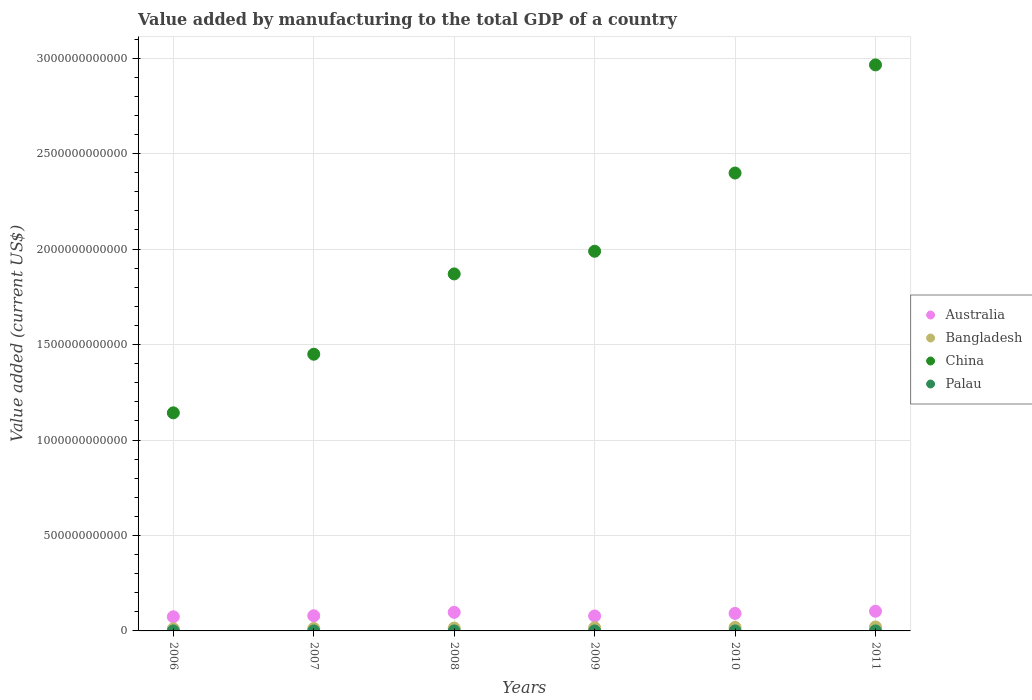What is the value added by manufacturing to the total GDP in Australia in 2008?
Keep it short and to the point. 9.74e+1. Across all years, what is the maximum value added by manufacturing to the total GDP in Palau?
Your response must be concise. 1.89e+06. Across all years, what is the minimum value added by manufacturing to the total GDP in China?
Your answer should be very brief. 1.14e+12. In which year was the value added by manufacturing to the total GDP in Bangladesh minimum?
Keep it short and to the point. 2006. What is the total value added by manufacturing to the total GDP in China in the graph?
Your response must be concise. 1.18e+13. What is the difference between the value added by manufacturing to the total GDP in China in 2007 and that in 2010?
Your answer should be compact. -9.49e+11. What is the difference between the value added by manufacturing to the total GDP in Australia in 2011 and the value added by manufacturing to the total GDP in China in 2009?
Ensure brevity in your answer.  -1.89e+12. What is the average value added by manufacturing to the total GDP in Bangladesh per year?
Keep it short and to the point. 1.58e+1. In the year 2007, what is the difference between the value added by manufacturing to the total GDP in China and value added by manufacturing to the total GDP in Australia?
Provide a short and direct response. 1.37e+12. What is the ratio of the value added by manufacturing to the total GDP in Palau in 2006 to that in 2011?
Give a very brief answer. 0.85. Is the value added by manufacturing to the total GDP in Palau in 2006 less than that in 2011?
Offer a terse response. Yes. Is the difference between the value added by manufacturing to the total GDP in China in 2009 and 2010 greater than the difference between the value added by manufacturing to the total GDP in Australia in 2009 and 2010?
Give a very brief answer. No. What is the difference between the highest and the second highest value added by manufacturing to the total GDP in Bangladesh?
Your answer should be compact. 1.99e+09. What is the difference between the highest and the lowest value added by manufacturing to the total GDP in China?
Your answer should be compact. 1.82e+12. Is the sum of the value added by manufacturing to the total GDP in Palau in 2009 and 2011 greater than the maximum value added by manufacturing to the total GDP in Australia across all years?
Make the answer very short. No. Is the value added by manufacturing to the total GDP in Palau strictly greater than the value added by manufacturing to the total GDP in China over the years?
Keep it short and to the point. No. How many years are there in the graph?
Keep it short and to the point. 6. What is the difference between two consecutive major ticks on the Y-axis?
Keep it short and to the point. 5.00e+11. Are the values on the major ticks of Y-axis written in scientific E-notation?
Give a very brief answer. No. Does the graph contain grids?
Your response must be concise. Yes. Where does the legend appear in the graph?
Ensure brevity in your answer.  Center right. How many legend labels are there?
Your answer should be compact. 4. How are the legend labels stacked?
Your answer should be very brief. Vertical. What is the title of the graph?
Offer a terse response. Value added by manufacturing to the total GDP of a country. Does "Seychelles" appear as one of the legend labels in the graph?
Provide a succinct answer. No. What is the label or title of the X-axis?
Keep it short and to the point. Years. What is the label or title of the Y-axis?
Offer a terse response. Value added (current US$). What is the Value added (current US$) in Australia in 2006?
Keep it short and to the point. 7.41e+1. What is the Value added (current US$) of Bangladesh in 2006?
Your answer should be very brief. 1.10e+1. What is the Value added (current US$) in China in 2006?
Keep it short and to the point. 1.14e+12. What is the Value added (current US$) in Palau in 2006?
Give a very brief answer. 1.52e+06. What is the Value added (current US$) of Australia in 2007?
Offer a very short reply. 7.95e+1. What is the Value added (current US$) in Bangladesh in 2007?
Offer a very short reply. 1.27e+1. What is the Value added (current US$) of China in 2007?
Keep it short and to the point. 1.45e+12. What is the Value added (current US$) in Palau in 2007?
Provide a succinct answer. 1.51e+06. What is the Value added (current US$) of Australia in 2008?
Make the answer very short. 9.74e+1. What is the Value added (current US$) in Bangladesh in 2008?
Offer a very short reply. 1.48e+1. What is the Value added (current US$) in China in 2008?
Your response must be concise. 1.87e+12. What is the Value added (current US$) of Palau in 2008?
Provide a short and direct response. 1.89e+06. What is the Value added (current US$) of Australia in 2009?
Offer a very short reply. 7.85e+1. What is the Value added (current US$) in Bangladesh in 2009?
Keep it short and to the point. 1.69e+1. What is the Value added (current US$) in China in 2009?
Ensure brevity in your answer.  1.99e+12. What is the Value added (current US$) in Palau in 2009?
Provide a succinct answer. 1.67e+06. What is the Value added (current US$) in Australia in 2010?
Your response must be concise. 9.17e+1. What is the Value added (current US$) of Bangladesh in 2010?
Give a very brief answer. 1.86e+1. What is the Value added (current US$) in China in 2010?
Your answer should be very brief. 2.40e+12. What is the Value added (current US$) in Palau in 2010?
Your response must be concise. 1.57e+06. What is the Value added (current US$) in Australia in 2011?
Provide a succinct answer. 1.03e+11. What is the Value added (current US$) in Bangladesh in 2011?
Make the answer very short. 2.06e+1. What is the Value added (current US$) of China in 2011?
Provide a short and direct response. 2.96e+12. What is the Value added (current US$) in Palau in 2011?
Your response must be concise. 1.79e+06. Across all years, what is the maximum Value added (current US$) in Australia?
Keep it short and to the point. 1.03e+11. Across all years, what is the maximum Value added (current US$) in Bangladesh?
Offer a very short reply. 2.06e+1. Across all years, what is the maximum Value added (current US$) in China?
Ensure brevity in your answer.  2.96e+12. Across all years, what is the maximum Value added (current US$) of Palau?
Your answer should be very brief. 1.89e+06. Across all years, what is the minimum Value added (current US$) of Australia?
Ensure brevity in your answer.  7.41e+1. Across all years, what is the minimum Value added (current US$) of Bangladesh?
Give a very brief answer. 1.10e+1. Across all years, what is the minimum Value added (current US$) in China?
Ensure brevity in your answer.  1.14e+12. Across all years, what is the minimum Value added (current US$) of Palau?
Your response must be concise. 1.51e+06. What is the total Value added (current US$) in Australia in the graph?
Keep it short and to the point. 5.24e+11. What is the total Value added (current US$) of Bangladesh in the graph?
Your response must be concise. 9.45e+1. What is the total Value added (current US$) of China in the graph?
Your answer should be compact. 1.18e+13. What is the total Value added (current US$) of Palau in the graph?
Your response must be concise. 9.95e+06. What is the difference between the Value added (current US$) of Australia in 2006 and that in 2007?
Keep it short and to the point. -5.44e+09. What is the difference between the Value added (current US$) of Bangladesh in 2006 and that in 2007?
Give a very brief answer. -1.69e+09. What is the difference between the Value added (current US$) of China in 2006 and that in 2007?
Your response must be concise. -3.07e+11. What is the difference between the Value added (current US$) in Palau in 2006 and that in 2007?
Your response must be concise. 8954.61. What is the difference between the Value added (current US$) in Australia in 2006 and that in 2008?
Offer a very short reply. -2.33e+1. What is the difference between the Value added (current US$) of Bangladesh in 2006 and that in 2008?
Your answer should be compact. -3.78e+09. What is the difference between the Value added (current US$) of China in 2006 and that in 2008?
Ensure brevity in your answer.  -7.28e+11. What is the difference between the Value added (current US$) in Palau in 2006 and that in 2008?
Your answer should be compact. -3.77e+05. What is the difference between the Value added (current US$) of Australia in 2006 and that in 2009?
Provide a short and direct response. -4.42e+09. What is the difference between the Value added (current US$) of Bangladesh in 2006 and that in 2009?
Give a very brief answer. -5.89e+09. What is the difference between the Value added (current US$) of China in 2006 and that in 2009?
Your answer should be very brief. -8.46e+11. What is the difference between the Value added (current US$) in Palau in 2006 and that in 2009?
Your answer should be very brief. -1.59e+05. What is the difference between the Value added (current US$) of Australia in 2006 and that in 2010?
Provide a succinct answer. -1.77e+1. What is the difference between the Value added (current US$) of Bangladesh in 2006 and that in 2010?
Keep it short and to the point. -7.59e+09. What is the difference between the Value added (current US$) of China in 2006 and that in 2010?
Make the answer very short. -1.26e+12. What is the difference between the Value added (current US$) in Palau in 2006 and that in 2010?
Give a very brief answer. -5.37e+04. What is the difference between the Value added (current US$) in Australia in 2006 and that in 2011?
Offer a very short reply. -2.90e+1. What is the difference between the Value added (current US$) of Bangladesh in 2006 and that in 2011?
Make the answer very short. -9.58e+09. What is the difference between the Value added (current US$) of China in 2006 and that in 2011?
Offer a terse response. -1.82e+12. What is the difference between the Value added (current US$) in Palau in 2006 and that in 2011?
Ensure brevity in your answer.  -2.74e+05. What is the difference between the Value added (current US$) in Australia in 2007 and that in 2008?
Offer a very short reply. -1.79e+1. What is the difference between the Value added (current US$) of Bangladesh in 2007 and that in 2008?
Your answer should be very brief. -2.09e+09. What is the difference between the Value added (current US$) in China in 2007 and that in 2008?
Ensure brevity in your answer.  -4.21e+11. What is the difference between the Value added (current US$) in Palau in 2007 and that in 2008?
Your answer should be compact. -3.86e+05. What is the difference between the Value added (current US$) of Australia in 2007 and that in 2009?
Your response must be concise. 1.02e+09. What is the difference between the Value added (current US$) in Bangladesh in 2007 and that in 2009?
Offer a very short reply. -4.20e+09. What is the difference between the Value added (current US$) in China in 2007 and that in 2009?
Provide a succinct answer. -5.39e+11. What is the difference between the Value added (current US$) in Palau in 2007 and that in 2009?
Your response must be concise. -1.68e+05. What is the difference between the Value added (current US$) in Australia in 2007 and that in 2010?
Ensure brevity in your answer.  -1.22e+1. What is the difference between the Value added (current US$) of Bangladesh in 2007 and that in 2010?
Provide a succinct answer. -5.90e+09. What is the difference between the Value added (current US$) in China in 2007 and that in 2010?
Your answer should be very brief. -9.49e+11. What is the difference between the Value added (current US$) of Palau in 2007 and that in 2010?
Your response must be concise. -6.27e+04. What is the difference between the Value added (current US$) in Australia in 2007 and that in 2011?
Ensure brevity in your answer.  -2.36e+1. What is the difference between the Value added (current US$) in Bangladesh in 2007 and that in 2011?
Keep it short and to the point. -7.89e+09. What is the difference between the Value added (current US$) in China in 2007 and that in 2011?
Offer a terse response. -1.52e+12. What is the difference between the Value added (current US$) of Palau in 2007 and that in 2011?
Your response must be concise. -2.83e+05. What is the difference between the Value added (current US$) of Australia in 2008 and that in 2009?
Your response must be concise. 1.89e+1. What is the difference between the Value added (current US$) in Bangladesh in 2008 and that in 2009?
Offer a very short reply. -2.11e+09. What is the difference between the Value added (current US$) of China in 2008 and that in 2009?
Provide a succinct answer. -1.19e+11. What is the difference between the Value added (current US$) in Palau in 2008 and that in 2009?
Give a very brief answer. 2.19e+05. What is the difference between the Value added (current US$) of Australia in 2008 and that in 2010?
Provide a succinct answer. 5.64e+09. What is the difference between the Value added (current US$) of Bangladesh in 2008 and that in 2010?
Provide a short and direct response. -3.81e+09. What is the difference between the Value added (current US$) of China in 2008 and that in 2010?
Provide a short and direct response. -5.29e+11. What is the difference between the Value added (current US$) in Palau in 2008 and that in 2010?
Your answer should be very brief. 3.24e+05. What is the difference between the Value added (current US$) of Australia in 2008 and that in 2011?
Offer a terse response. -5.73e+09. What is the difference between the Value added (current US$) of Bangladesh in 2008 and that in 2011?
Provide a short and direct response. -5.80e+09. What is the difference between the Value added (current US$) of China in 2008 and that in 2011?
Your answer should be compact. -1.09e+12. What is the difference between the Value added (current US$) in Palau in 2008 and that in 2011?
Ensure brevity in your answer.  1.03e+05. What is the difference between the Value added (current US$) in Australia in 2009 and that in 2010?
Your answer should be compact. -1.32e+1. What is the difference between the Value added (current US$) of Bangladesh in 2009 and that in 2010?
Your response must be concise. -1.70e+09. What is the difference between the Value added (current US$) of China in 2009 and that in 2010?
Offer a very short reply. -4.10e+11. What is the difference between the Value added (current US$) of Palau in 2009 and that in 2010?
Your answer should be compact. 1.05e+05. What is the difference between the Value added (current US$) of Australia in 2009 and that in 2011?
Your answer should be compact. -2.46e+1. What is the difference between the Value added (current US$) of Bangladesh in 2009 and that in 2011?
Make the answer very short. -3.69e+09. What is the difference between the Value added (current US$) of China in 2009 and that in 2011?
Give a very brief answer. -9.76e+11. What is the difference between the Value added (current US$) of Palau in 2009 and that in 2011?
Ensure brevity in your answer.  -1.16e+05. What is the difference between the Value added (current US$) in Australia in 2010 and that in 2011?
Your response must be concise. -1.14e+1. What is the difference between the Value added (current US$) in Bangladesh in 2010 and that in 2011?
Your answer should be compact. -1.99e+09. What is the difference between the Value added (current US$) of China in 2010 and that in 2011?
Your answer should be very brief. -5.66e+11. What is the difference between the Value added (current US$) of Palau in 2010 and that in 2011?
Your answer should be very brief. -2.21e+05. What is the difference between the Value added (current US$) in Australia in 2006 and the Value added (current US$) in Bangladesh in 2007?
Offer a terse response. 6.14e+1. What is the difference between the Value added (current US$) in Australia in 2006 and the Value added (current US$) in China in 2007?
Give a very brief answer. -1.38e+12. What is the difference between the Value added (current US$) in Australia in 2006 and the Value added (current US$) in Palau in 2007?
Provide a succinct answer. 7.41e+1. What is the difference between the Value added (current US$) of Bangladesh in 2006 and the Value added (current US$) of China in 2007?
Give a very brief answer. -1.44e+12. What is the difference between the Value added (current US$) of Bangladesh in 2006 and the Value added (current US$) of Palau in 2007?
Make the answer very short. 1.10e+1. What is the difference between the Value added (current US$) in China in 2006 and the Value added (current US$) in Palau in 2007?
Your answer should be very brief. 1.14e+12. What is the difference between the Value added (current US$) of Australia in 2006 and the Value added (current US$) of Bangladesh in 2008?
Keep it short and to the point. 5.93e+1. What is the difference between the Value added (current US$) of Australia in 2006 and the Value added (current US$) of China in 2008?
Give a very brief answer. -1.80e+12. What is the difference between the Value added (current US$) in Australia in 2006 and the Value added (current US$) in Palau in 2008?
Give a very brief answer. 7.41e+1. What is the difference between the Value added (current US$) of Bangladesh in 2006 and the Value added (current US$) of China in 2008?
Keep it short and to the point. -1.86e+12. What is the difference between the Value added (current US$) of Bangladesh in 2006 and the Value added (current US$) of Palau in 2008?
Ensure brevity in your answer.  1.10e+1. What is the difference between the Value added (current US$) in China in 2006 and the Value added (current US$) in Palau in 2008?
Offer a very short reply. 1.14e+12. What is the difference between the Value added (current US$) in Australia in 2006 and the Value added (current US$) in Bangladesh in 2009?
Make the answer very short. 5.72e+1. What is the difference between the Value added (current US$) of Australia in 2006 and the Value added (current US$) of China in 2009?
Make the answer very short. -1.91e+12. What is the difference between the Value added (current US$) in Australia in 2006 and the Value added (current US$) in Palau in 2009?
Your answer should be compact. 7.41e+1. What is the difference between the Value added (current US$) of Bangladesh in 2006 and the Value added (current US$) of China in 2009?
Offer a very short reply. -1.98e+12. What is the difference between the Value added (current US$) in Bangladesh in 2006 and the Value added (current US$) in Palau in 2009?
Keep it short and to the point. 1.10e+1. What is the difference between the Value added (current US$) of China in 2006 and the Value added (current US$) of Palau in 2009?
Give a very brief answer. 1.14e+12. What is the difference between the Value added (current US$) in Australia in 2006 and the Value added (current US$) in Bangladesh in 2010?
Your answer should be very brief. 5.55e+1. What is the difference between the Value added (current US$) of Australia in 2006 and the Value added (current US$) of China in 2010?
Your answer should be very brief. -2.32e+12. What is the difference between the Value added (current US$) of Australia in 2006 and the Value added (current US$) of Palau in 2010?
Provide a short and direct response. 7.41e+1. What is the difference between the Value added (current US$) of Bangladesh in 2006 and the Value added (current US$) of China in 2010?
Make the answer very short. -2.39e+12. What is the difference between the Value added (current US$) of Bangladesh in 2006 and the Value added (current US$) of Palau in 2010?
Your answer should be compact. 1.10e+1. What is the difference between the Value added (current US$) in China in 2006 and the Value added (current US$) in Palau in 2010?
Your answer should be compact. 1.14e+12. What is the difference between the Value added (current US$) in Australia in 2006 and the Value added (current US$) in Bangladesh in 2011?
Provide a short and direct response. 5.35e+1. What is the difference between the Value added (current US$) in Australia in 2006 and the Value added (current US$) in China in 2011?
Ensure brevity in your answer.  -2.89e+12. What is the difference between the Value added (current US$) of Australia in 2006 and the Value added (current US$) of Palau in 2011?
Provide a succinct answer. 7.41e+1. What is the difference between the Value added (current US$) of Bangladesh in 2006 and the Value added (current US$) of China in 2011?
Your response must be concise. -2.95e+12. What is the difference between the Value added (current US$) of Bangladesh in 2006 and the Value added (current US$) of Palau in 2011?
Make the answer very short. 1.10e+1. What is the difference between the Value added (current US$) in China in 2006 and the Value added (current US$) in Palau in 2011?
Make the answer very short. 1.14e+12. What is the difference between the Value added (current US$) of Australia in 2007 and the Value added (current US$) of Bangladesh in 2008?
Keep it short and to the point. 6.47e+1. What is the difference between the Value added (current US$) in Australia in 2007 and the Value added (current US$) in China in 2008?
Give a very brief answer. -1.79e+12. What is the difference between the Value added (current US$) of Australia in 2007 and the Value added (current US$) of Palau in 2008?
Give a very brief answer. 7.95e+1. What is the difference between the Value added (current US$) in Bangladesh in 2007 and the Value added (current US$) in China in 2008?
Provide a succinct answer. -1.86e+12. What is the difference between the Value added (current US$) in Bangladesh in 2007 and the Value added (current US$) in Palau in 2008?
Your answer should be compact. 1.27e+1. What is the difference between the Value added (current US$) in China in 2007 and the Value added (current US$) in Palau in 2008?
Offer a very short reply. 1.45e+12. What is the difference between the Value added (current US$) of Australia in 2007 and the Value added (current US$) of Bangladesh in 2009?
Provide a succinct answer. 6.26e+1. What is the difference between the Value added (current US$) of Australia in 2007 and the Value added (current US$) of China in 2009?
Your response must be concise. -1.91e+12. What is the difference between the Value added (current US$) in Australia in 2007 and the Value added (current US$) in Palau in 2009?
Keep it short and to the point. 7.95e+1. What is the difference between the Value added (current US$) of Bangladesh in 2007 and the Value added (current US$) of China in 2009?
Give a very brief answer. -1.98e+12. What is the difference between the Value added (current US$) in Bangladesh in 2007 and the Value added (current US$) in Palau in 2009?
Your answer should be very brief. 1.27e+1. What is the difference between the Value added (current US$) of China in 2007 and the Value added (current US$) of Palau in 2009?
Offer a terse response. 1.45e+12. What is the difference between the Value added (current US$) in Australia in 2007 and the Value added (current US$) in Bangladesh in 2010?
Provide a short and direct response. 6.09e+1. What is the difference between the Value added (current US$) of Australia in 2007 and the Value added (current US$) of China in 2010?
Provide a succinct answer. -2.32e+12. What is the difference between the Value added (current US$) in Australia in 2007 and the Value added (current US$) in Palau in 2010?
Provide a succinct answer. 7.95e+1. What is the difference between the Value added (current US$) of Bangladesh in 2007 and the Value added (current US$) of China in 2010?
Provide a succinct answer. -2.39e+12. What is the difference between the Value added (current US$) in Bangladesh in 2007 and the Value added (current US$) in Palau in 2010?
Keep it short and to the point. 1.27e+1. What is the difference between the Value added (current US$) in China in 2007 and the Value added (current US$) in Palau in 2010?
Your answer should be compact. 1.45e+12. What is the difference between the Value added (current US$) in Australia in 2007 and the Value added (current US$) in Bangladesh in 2011?
Keep it short and to the point. 5.89e+1. What is the difference between the Value added (current US$) in Australia in 2007 and the Value added (current US$) in China in 2011?
Offer a very short reply. -2.89e+12. What is the difference between the Value added (current US$) in Australia in 2007 and the Value added (current US$) in Palau in 2011?
Ensure brevity in your answer.  7.95e+1. What is the difference between the Value added (current US$) in Bangladesh in 2007 and the Value added (current US$) in China in 2011?
Your response must be concise. -2.95e+12. What is the difference between the Value added (current US$) in Bangladesh in 2007 and the Value added (current US$) in Palau in 2011?
Your answer should be compact. 1.27e+1. What is the difference between the Value added (current US$) in China in 2007 and the Value added (current US$) in Palau in 2011?
Offer a terse response. 1.45e+12. What is the difference between the Value added (current US$) of Australia in 2008 and the Value added (current US$) of Bangladesh in 2009?
Make the answer very short. 8.05e+1. What is the difference between the Value added (current US$) of Australia in 2008 and the Value added (current US$) of China in 2009?
Provide a succinct answer. -1.89e+12. What is the difference between the Value added (current US$) in Australia in 2008 and the Value added (current US$) in Palau in 2009?
Your answer should be very brief. 9.74e+1. What is the difference between the Value added (current US$) in Bangladesh in 2008 and the Value added (current US$) in China in 2009?
Your answer should be very brief. -1.97e+12. What is the difference between the Value added (current US$) in Bangladesh in 2008 and the Value added (current US$) in Palau in 2009?
Ensure brevity in your answer.  1.48e+1. What is the difference between the Value added (current US$) of China in 2008 and the Value added (current US$) of Palau in 2009?
Ensure brevity in your answer.  1.87e+12. What is the difference between the Value added (current US$) of Australia in 2008 and the Value added (current US$) of Bangladesh in 2010?
Provide a short and direct response. 7.88e+1. What is the difference between the Value added (current US$) of Australia in 2008 and the Value added (current US$) of China in 2010?
Give a very brief answer. -2.30e+12. What is the difference between the Value added (current US$) in Australia in 2008 and the Value added (current US$) in Palau in 2010?
Your answer should be very brief. 9.74e+1. What is the difference between the Value added (current US$) of Bangladesh in 2008 and the Value added (current US$) of China in 2010?
Ensure brevity in your answer.  -2.38e+12. What is the difference between the Value added (current US$) in Bangladesh in 2008 and the Value added (current US$) in Palau in 2010?
Your answer should be very brief. 1.48e+1. What is the difference between the Value added (current US$) of China in 2008 and the Value added (current US$) of Palau in 2010?
Provide a succinct answer. 1.87e+12. What is the difference between the Value added (current US$) in Australia in 2008 and the Value added (current US$) in Bangladesh in 2011?
Provide a succinct answer. 7.68e+1. What is the difference between the Value added (current US$) of Australia in 2008 and the Value added (current US$) of China in 2011?
Give a very brief answer. -2.87e+12. What is the difference between the Value added (current US$) of Australia in 2008 and the Value added (current US$) of Palau in 2011?
Provide a succinct answer. 9.74e+1. What is the difference between the Value added (current US$) of Bangladesh in 2008 and the Value added (current US$) of China in 2011?
Keep it short and to the point. -2.95e+12. What is the difference between the Value added (current US$) in Bangladesh in 2008 and the Value added (current US$) in Palau in 2011?
Offer a terse response. 1.48e+1. What is the difference between the Value added (current US$) in China in 2008 and the Value added (current US$) in Palau in 2011?
Make the answer very short. 1.87e+12. What is the difference between the Value added (current US$) in Australia in 2009 and the Value added (current US$) in Bangladesh in 2010?
Offer a very short reply. 5.99e+1. What is the difference between the Value added (current US$) of Australia in 2009 and the Value added (current US$) of China in 2010?
Make the answer very short. -2.32e+12. What is the difference between the Value added (current US$) in Australia in 2009 and the Value added (current US$) in Palau in 2010?
Offer a very short reply. 7.85e+1. What is the difference between the Value added (current US$) in Bangladesh in 2009 and the Value added (current US$) in China in 2010?
Give a very brief answer. -2.38e+12. What is the difference between the Value added (current US$) of Bangladesh in 2009 and the Value added (current US$) of Palau in 2010?
Ensure brevity in your answer.  1.69e+1. What is the difference between the Value added (current US$) of China in 2009 and the Value added (current US$) of Palau in 2010?
Your response must be concise. 1.99e+12. What is the difference between the Value added (current US$) of Australia in 2009 and the Value added (current US$) of Bangladesh in 2011?
Make the answer very short. 5.79e+1. What is the difference between the Value added (current US$) of Australia in 2009 and the Value added (current US$) of China in 2011?
Provide a short and direct response. -2.89e+12. What is the difference between the Value added (current US$) in Australia in 2009 and the Value added (current US$) in Palau in 2011?
Your answer should be very brief. 7.85e+1. What is the difference between the Value added (current US$) of Bangladesh in 2009 and the Value added (current US$) of China in 2011?
Provide a succinct answer. -2.95e+12. What is the difference between the Value added (current US$) in Bangladesh in 2009 and the Value added (current US$) in Palau in 2011?
Your answer should be very brief. 1.69e+1. What is the difference between the Value added (current US$) in China in 2009 and the Value added (current US$) in Palau in 2011?
Give a very brief answer. 1.99e+12. What is the difference between the Value added (current US$) in Australia in 2010 and the Value added (current US$) in Bangladesh in 2011?
Your response must be concise. 7.11e+1. What is the difference between the Value added (current US$) of Australia in 2010 and the Value added (current US$) of China in 2011?
Make the answer very short. -2.87e+12. What is the difference between the Value added (current US$) of Australia in 2010 and the Value added (current US$) of Palau in 2011?
Give a very brief answer. 9.17e+1. What is the difference between the Value added (current US$) in Bangladesh in 2010 and the Value added (current US$) in China in 2011?
Give a very brief answer. -2.95e+12. What is the difference between the Value added (current US$) of Bangladesh in 2010 and the Value added (current US$) of Palau in 2011?
Offer a very short reply. 1.86e+1. What is the difference between the Value added (current US$) of China in 2010 and the Value added (current US$) of Palau in 2011?
Keep it short and to the point. 2.40e+12. What is the average Value added (current US$) in Australia per year?
Your answer should be very brief. 8.74e+1. What is the average Value added (current US$) of Bangladesh per year?
Provide a short and direct response. 1.58e+1. What is the average Value added (current US$) of China per year?
Your answer should be compact. 1.97e+12. What is the average Value added (current US$) in Palau per year?
Your answer should be very brief. 1.66e+06. In the year 2006, what is the difference between the Value added (current US$) in Australia and Value added (current US$) in Bangladesh?
Your response must be concise. 6.31e+1. In the year 2006, what is the difference between the Value added (current US$) of Australia and Value added (current US$) of China?
Give a very brief answer. -1.07e+12. In the year 2006, what is the difference between the Value added (current US$) of Australia and Value added (current US$) of Palau?
Your response must be concise. 7.41e+1. In the year 2006, what is the difference between the Value added (current US$) of Bangladesh and Value added (current US$) of China?
Give a very brief answer. -1.13e+12. In the year 2006, what is the difference between the Value added (current US$) in Bangladesh and Value added (current US$) in Palau?
Offer a very short reply. 1.10e+1. In the year 2006, what is the difference between the Value added (current US$) of China and Value added (current US$) of Palau?
Offer a terse response. 1.14e+12. In the year 2007, what is the difference between the Value added (current US$) of Australia and Value added (current US$) of Bangladesh?
Ensure brevity in your answer.  6.68e+1. In the year 2007, what is the difference between the Value added (current US$) in Australia and Value added (current US$) in China?
Offer a very short reply. -1.37e+12. In the year 2007, what is the difference between the Value added (current US$) of Australia and Value added (current US$) of Palau?
Your response must be concise. 7.95e+1. In the year 2007, what is the difference between the Value added (current US$) in Bangladesh and Value added (current US$) in China?
Offer a terse response. -1.44e+12. In the year 2007, what is the difference between the Value added (current US$) in Bangladesh and Value added (current US$) in Palau?
Your answer should be compact. 1.27e+1. In the year 2007, what is the difference between the Value added (current US$) of China and Value added (current US$) of Palau?
Keep it short and to the point. 1.45e+12. In the year 2008, what is the difference between the Value added (current US$) in Australia and Value added (current US$) in Bangladesh?
Your response must be concise. 8.26e+1. In the year 2008, what is the difference between the Value added (current US$) in Australia and Value added (current US$) in China?
Offer a terse response. -1.77e+12. In the year 2008, what is the difference between the Value added (current US$) in Australia and Value added (current US$) in Palau?
Ensure brevity in your answer.  9.74e+1. In the year 2008, what is the difference between the Value added (current US$) of Bangladesh and Value added (current US$) of China?
Keep it short and to the point. -1.86e+12. In the year 2008, what is the difference between the Value added (current US$) of Bangladesh and Value added (current US$) of Palau?
Provide a succinct answer. 1.48e+1. In the year 2008, what is the difference between the Value added (current US$) in China and Value added (current US$) in Palau?
Your answer should be compact. 1.87e+12. In the year 2009, what is the difference between the Value added (current US$) of Australia and Value added (current US$) of Bangladesh?
Keep it short and to the point. 6.16e+1. In the year 2009, what is the difference between the Value added (current US$) in Australia and Value added (current US$) in China?
Ensure brevity in your answer.  -1.91e+12. In the year 2009, what is the difference between the Value added (current US$) in Australia and Value added (current US$) in Palau?
Give a very brief answer. 7.85e+1. In the year 2009, what is the difference between the Value added (current US$) in Bangladesh and Value added (current US$) in China?
Give a very brief answer. -1.97e+12. In the year 2009, what is the difference between the Value added (current US$) in Bangladesh and Value added (current US$) in Palau?
Offer a terse response. 1.69e+1. In the year 2009, what is the difference between the Value added (current US$) of China and Value added (current US$) of Palau?
Give a very brief answer. 1.99e+12. In the year 2010, what is the difference between the Value added (current US$) in Australia and Value added (current US$) in Bangladesh?
Your answer should be very brief. 7.31e+1. In the year 2010, what is the difference between the Value added (current US$) in Australia and Value added (current US$) in China?
Your answer should be compact. -2.31e+12. In the year 2010, what is the difference between the Value added (current US$) in Australia and Value added (current US$) in Palau?
Offer a very short reply. 9.17e+1. In the year 2010, what is the difference between the Value added (current US$) in Bangladesh and Value added (current US$) in China?
Your answer should be very brief. -2.38e+12. In the year 2010, what is the difference between the Value added (current US$) in Bangladesh and Value added (current US$) in Palau?
Ensure brevity in your answer.  1.86e+1. In the year 2010, what is the difference between the Value added (current US$) in China and Value added (current US$) in Palau?
Keep it short and to the point. 2.40e+12. In the year 2011, what is the difference between the Value added (current US$) in Australia and Value added (current US$) in Bangladesh?
Make the answer very short. 8.25e+1. In the year 2011, what is the difference between the Value added (current US$) of Australia and Value added (current US$) of China?
Your answer should be compact. -2.86e+12. In the year 2011, what is the difference between the Value added (current US$) of Australia and Value added (current US$) of Palau?
Give a very brief answer. 1.03e+11. In the year 2011, what is the difference between the Value added (current US$) in Bangladesh and Value added (current US$) in China?
Keep it short and to the point. -2.94e+12. In the year 2011, what is the difference between the Value added (current US$) in Bangladesh and Value added (current US$) in Palau?
Keep it short and to the point. 2.06e+1. In the year 2011, what is the difference between the Value added (current US$) in China and Value added (current US$) in Palau?
Keep it short and to the point. 2.96e+12. What is the ratio of the Value added (current US$) in Australia in 2006 to that in 2007?
Offer a terse response. 0.93. What is the ratio of the Value added (current US$) of Bangladesh in 2006 to that in 2007?
Offer a terse response. 0.87. What is the ratio of the Value added (current US$) of China in 2006 to that in 2007?
Ensure brevity in your answer.  0.79. What is the ratio of the Value added (current US$) in Palau in 2006 to that in 2007?
Your answer should be compact. 1.01. What is the ratio of the Value added (current US$) in Australia in 2006 to that in 2008?
Give a very brief answer. 0.76. What is the ratio of the Value added (current US$) of Bangladesh in 2006 to that in 2008?
Provide a succinct answer. 0.74. What is the ratio of the Value added (current US$) of China in 2006 to that in 2008?
Provide a short and direct response. 0.61. What is the ratio of the Value added (current US$) of Palau in 2006 to that in 2008?
Make the answer very short. 0.8. What is the ratio of the Value added (current US$) of Australia in 2006 to that in 2009?
Keep it short and to the point. 0.94. What is the ratio of the Value added (current US$) in Bangladesh in 2006 to that in 2009?
Offer a terse response. 0.65. What is the ratio of the Value added (current US$) in China in 2006 to that in 2009?
Your response must be concise. 0.57. What is the ratio of the Value added (current US$) of Palau in 2006 to that in 2009?
Provide a succinct answer. 0.91. What is the ratio of the Value added (current US$) in Australia in 2006 to that in 2010?
Give a very brief answer. 0.81. What is the ratio of the Value added (current US$) of Bangladesh in 2006 to that in 2010?
Make the answer very short. 0.59. What is the ratio of the Value added (current US$) in China in 2006 to that in 2010?
Make the answer very short. 0.48. What is the ratio of the Value added (current US$) in Palau in 2006 to that in 2010?
Give a very brief answer. 0.97. What is the ratio of the Value added (current US$) in Australia in 2006 to that in 2011?
Your response must be concise. 0.72. What is the ratio of the Value added (current US$) in Bangladesh in 2006 to that in 2011?
Your answer should be compact. 0.53. What is the ratio of the Value added (current US$) in China in 2006 to that in 2011?
Offer a terse response. 0.39. What is the ratio of the Value added (current US$) in Palau in 2006 to that in 2011?
Your response must be concise. 0.85. What is the ratio of the Value added (current US$) of Australia in 2007 to that in 2008?
Ensure brevity in your answer.  0.82. What is the ratio of the Value added (current US$) in Bangladesh in 2007 to that in 2008?
Keep it short and to the point. 0.86. What is the ratio of the Value added (current US$) in China in 2007 to that in 2008?
Offer a very short reply. 0.78. What is the ratio of the Value added (current US$) in Palau in 2007 to that in 2008?
Offer a very short reply. 0.8. What is the ratio of the Value added (current US$) of Bangladesh in 2007 to that in 2009?
Provide a succinct answer. 0.75. What is the ratio of the Value added (current US$) in China in 2007 to that in 2009?
Offer a very short reply. 0.73. What is the ratio of the Value added (current US$) in Australia in 2007 to that in 2010?
Provide a short and direct response. 0.87. What is the ratio of the Value added (current US$) of Bangladesh in 2007 to that in 2010?
Provide a short and direct response. 0.68. What is the ratio of the Value added (current US$) in China in 2007 to that in 2010?
Keep it short and to the point. 0.6. What is the ratio of the Value added (current US$) in Palau in 2007 to that in 2010?
Offer a terse response. 0.96. What is the ratio of the Value added (current US$) in Australia in 2007 to that in 2011?
Provide a succinct answer. 0.77. What is the ratio of the Value added (current US$) of Bangladesh in 2007 to that in 2011?
Your answer should be very brief. 0.62. What is the ratio of the Value added (current US$) in China in 2007 to that in 2011?
Keep it short and to the point. 0.49. What is the ratio of the Value added (current US$) in Palau in 2007 to that in 2011?
Keep it short and to the point. 0.84. What is the ratio of the Value added (current US$) in Australia in 2008 to that in 2009?
Your answer should be very brief. 1.24. What is the ratio of the Value added (current US$) in Bangladesh in 2008 to that in 2009?
Provide a short and direct response. 0.87. What is the ratio of the Value added (current US$) of China in 2008 to that in 2009?
Offer a very short reply. 0.94. What is the ratio of the Value added (current US$) of Palau in 2008 to that in 2009?
Your answer should be very brief. 1.13. What is the ratio of the Value added (current US$) in Australia in 2008 to that in 2010?
Your response must be concise. 1.06. What is the ratio of the Value added (current US$) in Bangladesh in 2008 to that in 2010?
Keep it short and to the point. 0.8. What is the ratio of the Value added (current US$) in China in 2008 to that in 2010?
Your response must be concise. 0.78. What is the ratio of the Value added (current US$) of Palau in 2008 to that in 2010?
Offer a very short reply. 1.21. What is the ratio of the Value added (current US$) of Bangladesh in 2008 to that in 2011?
Your answer should be very brief. 0.72. What is the ratio of the Value added (current US$) in China in 2008 to that in 2011?
Give a very brief answer. 0.63. What is the ratio of the Value added (current US$) of Palau in 2008 to that in 2011?
Offer a very short reply. 1.06. What is the ratio of the Value added (current US$) of Australia in 2009 to that in 2010?
Provide a short and direct response. 0.86. What is the ratio of the Value added (current US$) in Bangladesh in 2009 to that in 2010?
Offer a very short reply. 0.91. What is the ratio of the Value added (current US$) of China in 2009 to that in 2010?
Ensure brevity in your answer.  0.83. What is the ratio of the Value added (current US$) of Palau in 2009 to that in 2010?
Ensure brevity in your answer.  1.07. What is the ratio of the Value added (current US$) of Australia in 2009 to that in 2011?
Give a very brief answer. 0.76. What is the ratio of the Value added (current US$) of Bangladesh in 2009 to that in 2011?
Offer a very short reply. 0.82. What is the ratio of the Value added (current US$) of China in 2009 to that in 2011?
Offer a terse response. 0.67. What is the ratio of the Value added (current US$) of Palau in 2009 to that in 2011?
Ensure brevity in your answer.  0.94. What is the ratio of the Value added (current US$) in Australia in 2010 to that in 2011?
Offer a terse response. 0.89. What is the ratio of the Value added (current US$) of Bangladesh in 2010 to that in 2011?
Your answer should be very brief. 0.9. What is the ratio of the Value added (current US$) of China in 2010 to that in 2011?
Your answer should be compact. 0.81. What is the ratio of the Value added (current US$) of Palau in 2010 to that in 2011?
Offer a terse response. 0.88. What is the difference between the highest and the second highest Value added (current US$) in Australia?
Offer a very short reply. 5.73e+09. What is the difference between the highest and the second highest Value added (current US$) in Bangladesh?
Offer a very short reply. 1.99e+09. What is the difference between the highest and the second highest Value added (current US$) in China?
Provide a short and direct response. 5.66e+11. What is the difference between the highest and the second highest Value added (current US$) of Palau?
Give a very brief answer. 1.03e+05. What is the difference between the highest and the lowest Value added (current US$) of Australia?
Provide a succinct answer. 2.90e+1. What is the difference between the highest and the lowest Value added (current US$) of Bangladesh?
Offer a terse response. 9.58e+09. What is the difference between the highest and the lowest Value added (current US$) in China?
Ensure brevity in your answer.  1.82e+12. What is the difference between the highest and the lowest Value added (current US$) in Palau?
Give a very brief answer. 3.86e+05. 